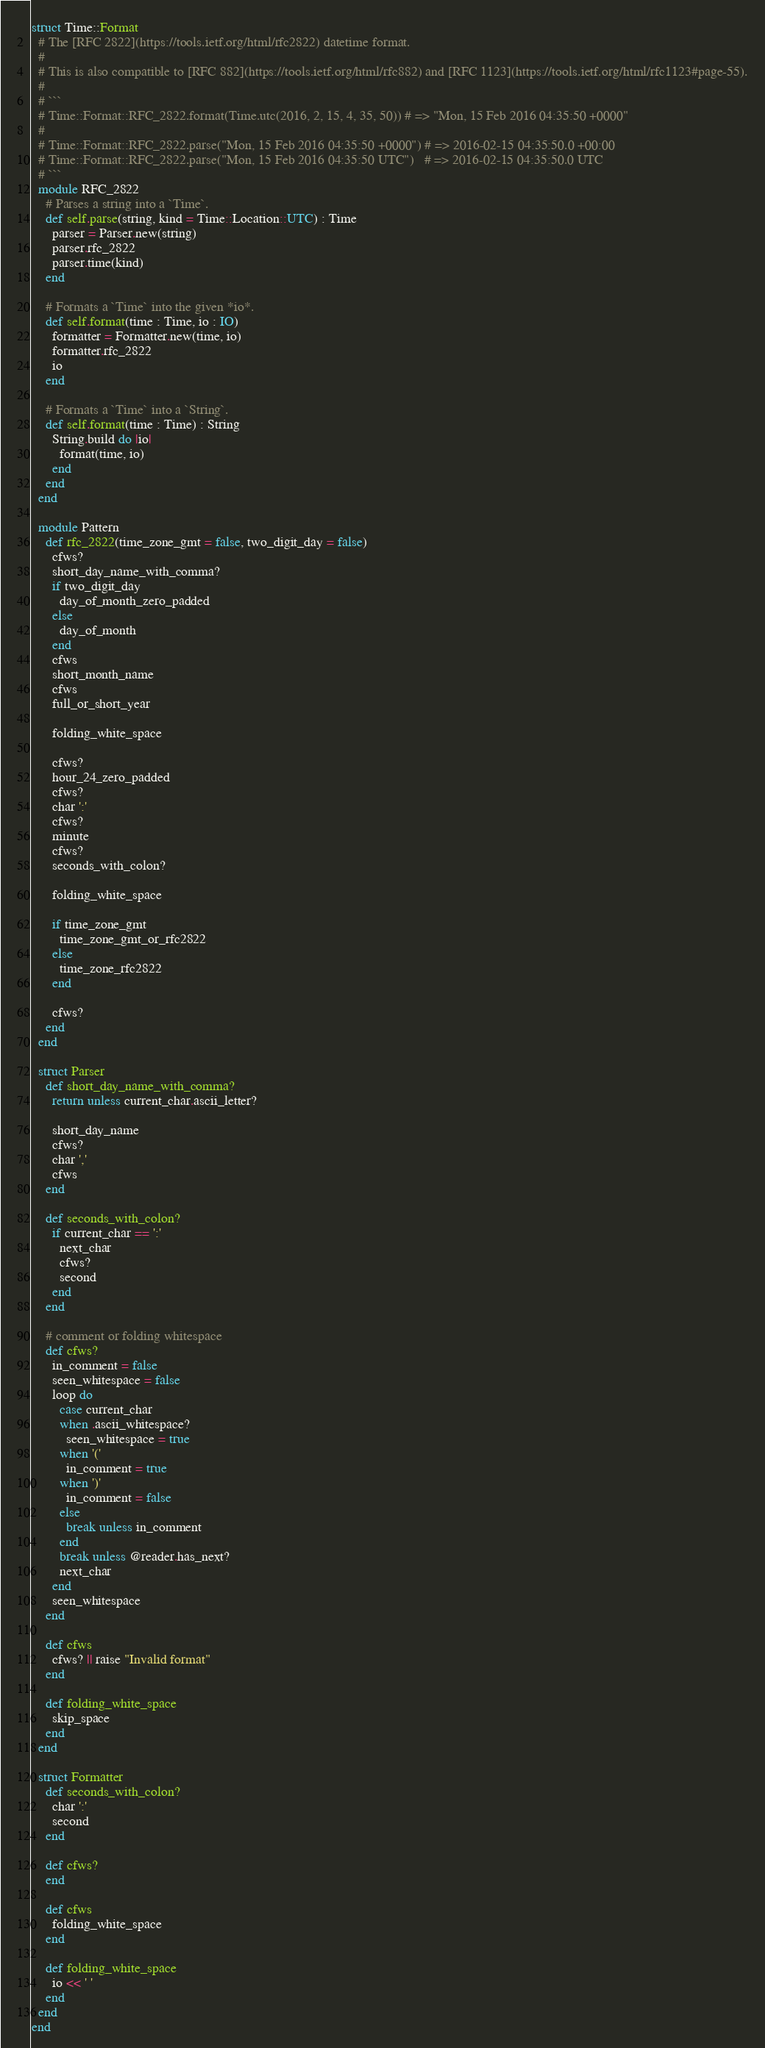<code> <loc_0><loc_0><loc_500><loc_500><_Crystal_>struct Time::Format
  # The [RFC 2822](https://tools.ietf.org/html/rfc2822) datetime format.
  #
  # This is also compatible to [RFC 882](https://tools.ietf.org/html/rfc882) and [RFC 1123](https://tools.ietf.org/html/rfc1123#page-55).
  #
  # ```
  # Time::Format::RFC_2822.format(Time.utc(2016, 2, 15, 4, 35, 50)) # => "Mon, 15 Feb 2016 04:35:50 +0000"
  #
  # Time::Format::RFC_2822.parse("Mon, 15 Feb 2016 04:35:50 +0000") # => 2016-02-15 04:35:50.0 +00:00
  # Time::Format::RFC_2822.parse("Mon, 15 Feb 2016 04:35:50 UTC")   # => 2016-02-15 04:35:50.0 UTC
  # ```
  module RFC_2822
    # Parses a string into a `Time`.
    def self.parse(string, kind = Time::Location::UTC) : Time
      parser = Parser.new(string)
      parser.rfc_2822
      parser.time(kind)
    end

    # Formats a `Time` into the given *io*.
    def self.format(time : Time, io : IO)
      formatter = Formatter.new(time, io)
      formatter.rfc_2822
      io
    end

    # Formats a `Time` into a `String`.
    def self.format(time : Time) : String
      String.build do |io|
        format(time, io)
      end
    end
  end

  module Pattern
    def rfc_2822(time_zone_gmt = false, two_digit_day = false)
      cfws?
      short_day_name_with_comma?
      if two_digit_day
        day_of_month_zero_padded
      else
        day_of_month
      end
      cfws
      short_month_name
      cfws
      full_or_short_year

      folding_white_space

      cfws?
      hour_24_zero_padded
      cfws?
      char ':'
      cfws?
      minute
      cfws?
      seconds_with_colon?

      folding_white_space

      if time_zone_gmt
        time_zone_gmt_or_rfc2822
      else
        time_zone_rfc2822
      end

      cfws?
    end
  end

  struct Parser
    def short_day_name_with_comma?
      return unless current_char.ascii_letter?

      short_day_name
      cfws?
      char ','
      cfws
    end

    def seconds_with_colon?
      if current_char == ':'
        next_char
        cfws?
        second
      end
    end

    # comment or folding whitespace
    def cfws?
      in_comment = false
      seen_whitespace = false
      loop do
        case current_char
        when .ascii_whitespace?
          seen_whitespace = true
        when '('
          in_comment = true
        when ')'
          in_comment = false
        else
          break unless in_comment
        end
        break unless @reader.has_next?
        next_char
      end
      seen_whitespace
    end

    def cfws
      cfws? || raise "Invalid format"
    end

    def folding_white_space
      skip_space
    end
  end

  struct Formatter
    def seconds_with_colon?
      char ':'
      second
    end

    def cfws?
    end

    def cfws
      folding_white_space
    end

    def folding_white_space
      io << ' '
    end
  end
end
</code> 